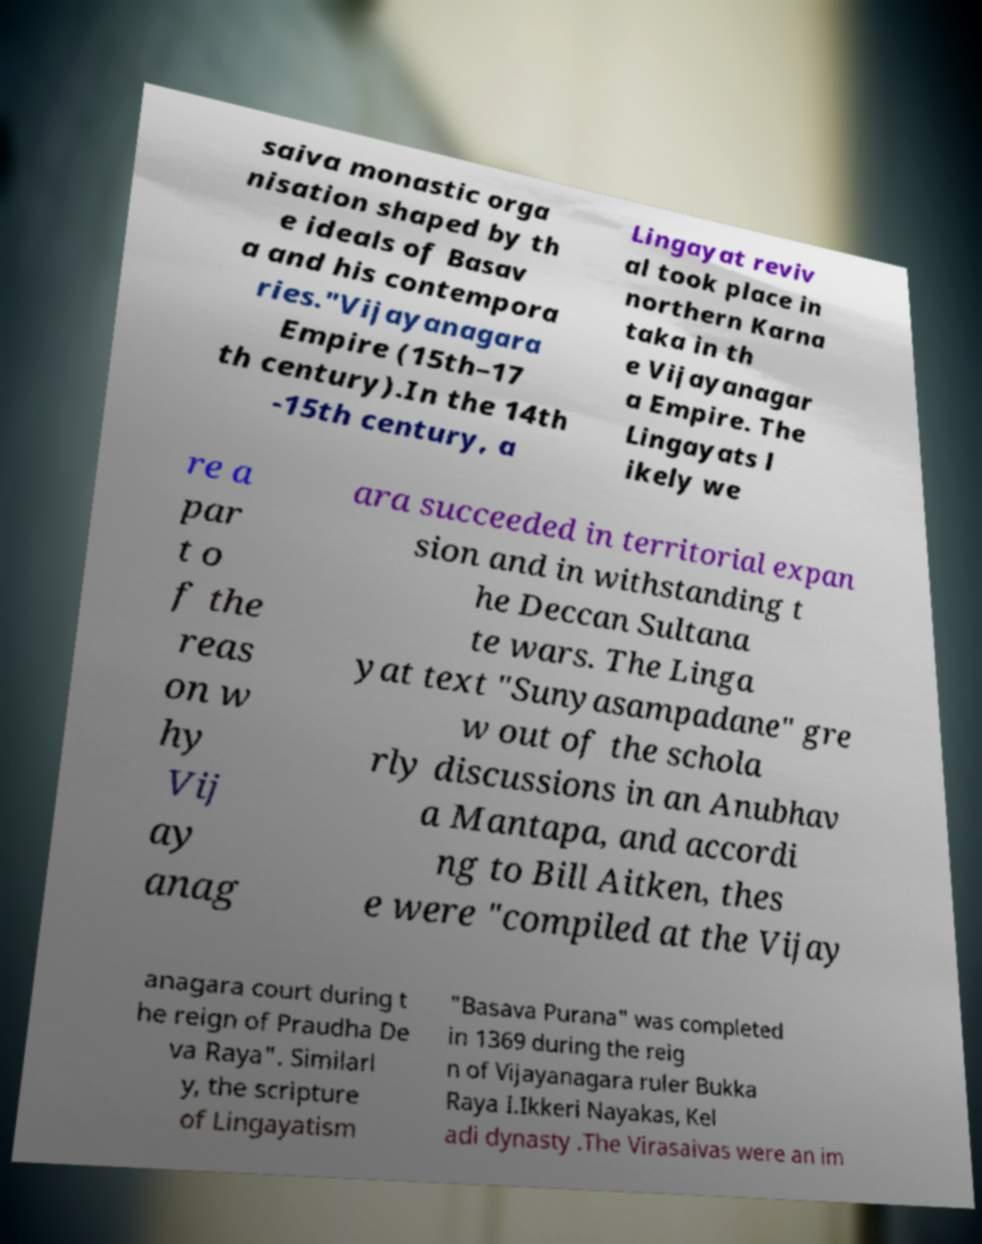Please identify and transcribe the text found in this image. saiva monastic orga nisation shaped by th e ideals of Basav a and his contempora ries."Vijayanagara Empire (15th–17 th century).In the 14th -15th century, a Lingayat reviv al took place in northern Karna taka in th e Vijayanagar a Empire. The Lingayats l ikely we re a par t o f the reas on w hy Vij ay anag ara succeeded in territorial expan sion and in withstanding t he Deccan Sultana te wars. The Linga yat text "Sunyasampadane" gre w out of the schola rly discussions in an Anubhav a Mantapa, and accordi ng to Bill Aitken, thes e were "compiled at the Vijay anagara court during t he reign of Praudha De va Raya". Similarl y, the scripture of Lingayatism "Basava Purana" was completed in 1369 during the reig n of Vijayanagara ruler Bukka Raya I.Ikkeri Nayakas, Kel adi dynasty .The Virasaivas were an im 